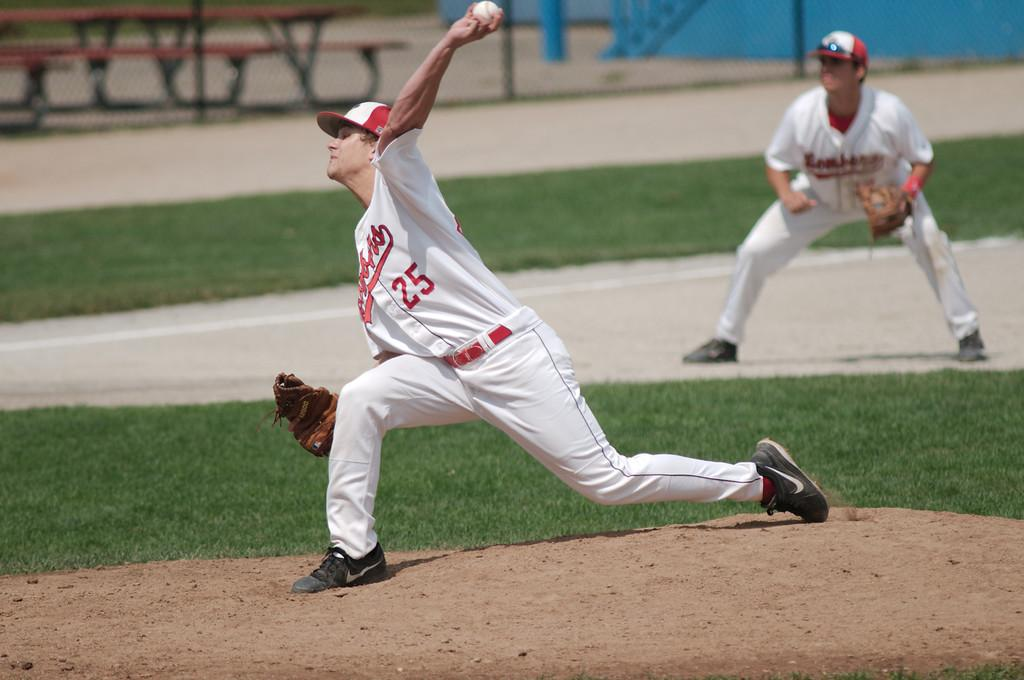<image>
Offer a succinct explanation of the picture presented. A baseball player with the number 25 on his shirt. 